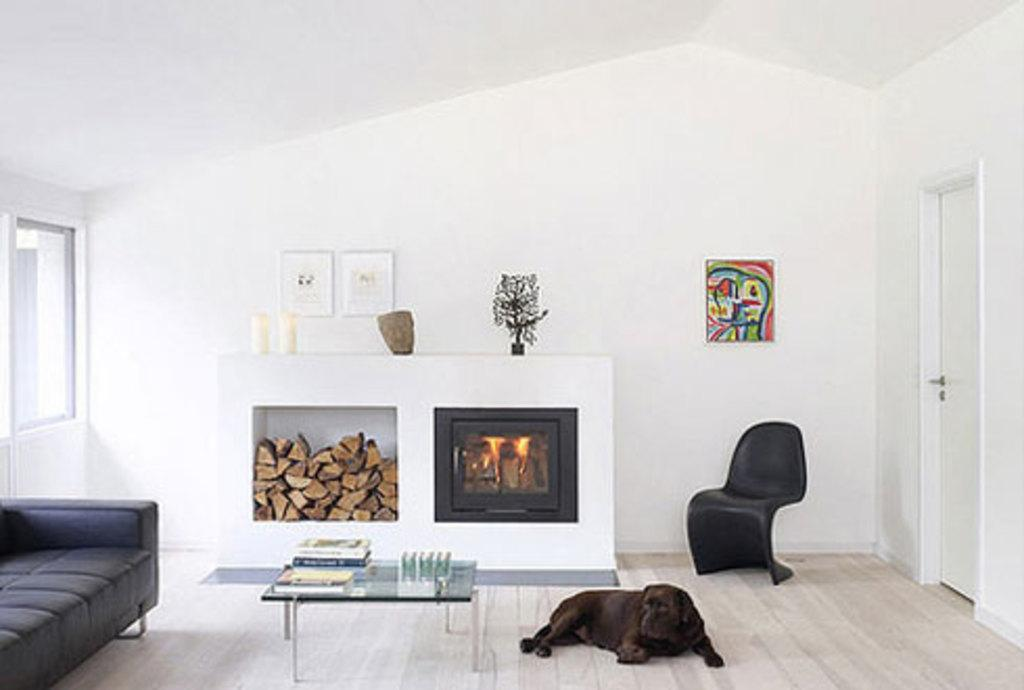What type of furniture is present in the image? There is a table and a couch on the floor in the image. What kind of animal can be seen in the image? There is a dog in the image. What architectural features are visible in the image? There is a door and a window in the image. What is the color of the wall in the image? There is a white color wall in the image. What is hanging on the wall in the image? There is a photo on the wall in the image. What type of sink can be seen in the image? There is no sink present in the image. What verse is written on the wall in the image? There is no verse written on the wall in the image; it only has a photo hanging on it. 